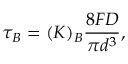Convert formula to latex. <formula><loc_0><loc_0><loc_500><loc_500>\tau _ { B } = ( K ) _ { B } \frac { 8 F D } { \pi d ^ { 3 } } ,</formula> 